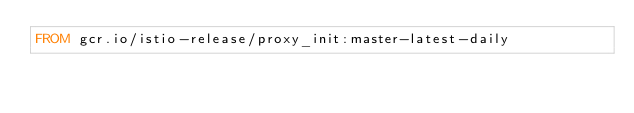<code> <loc_0><loc_0><loc_500><loc_500><_Dockerfile_>FROM gcr.io/istio-release/proxy_init:master-latest-daily
</code> 